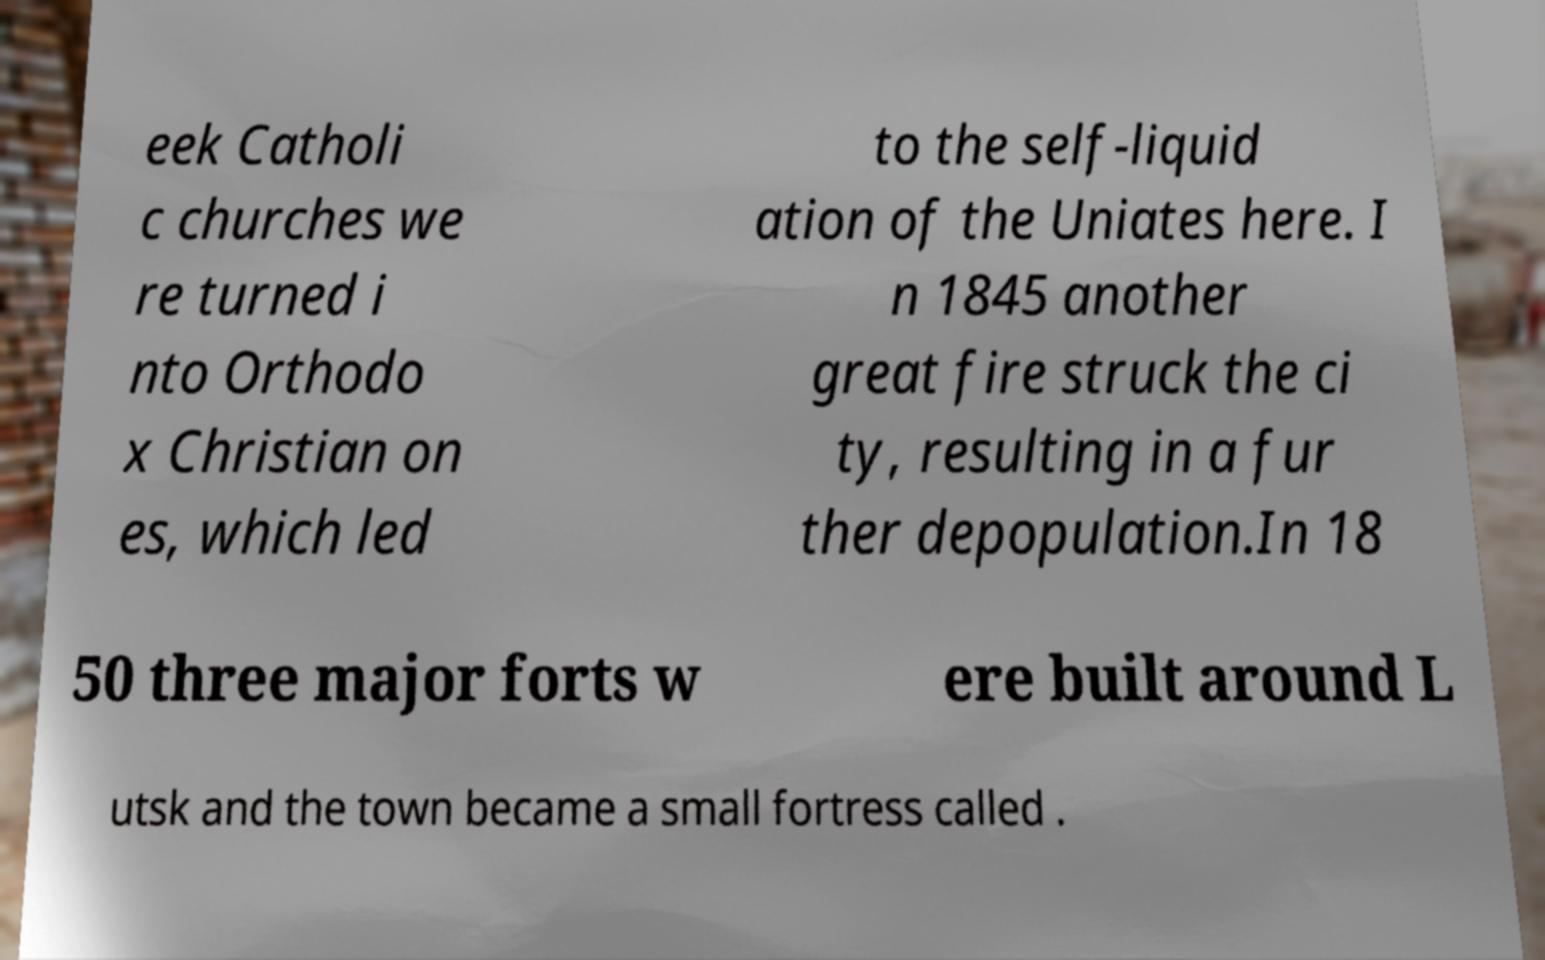There's text embedded in this image that I need extracted. Can you transcribe it verbatim? eek Catholi c churches we re turned i nto Orthodo x Christian on es, which led to the self-liquid ation of the Uniates here. I n 1845 another great fire struck the ci ty, resulting in a fur ther depopulation.In 18 50 three major forts w ere built around L utsk and the town became a small fortress called . 